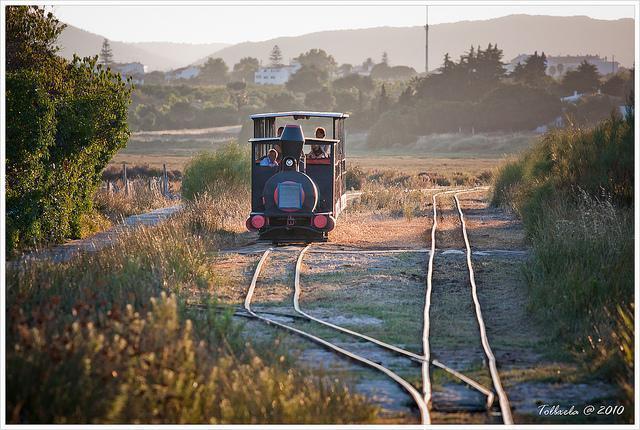How far will this train travel usually?
From the following four choices, select the correct answer to address the question.
Options: 1000 miles, local only, far away, nowhere. Local only. 